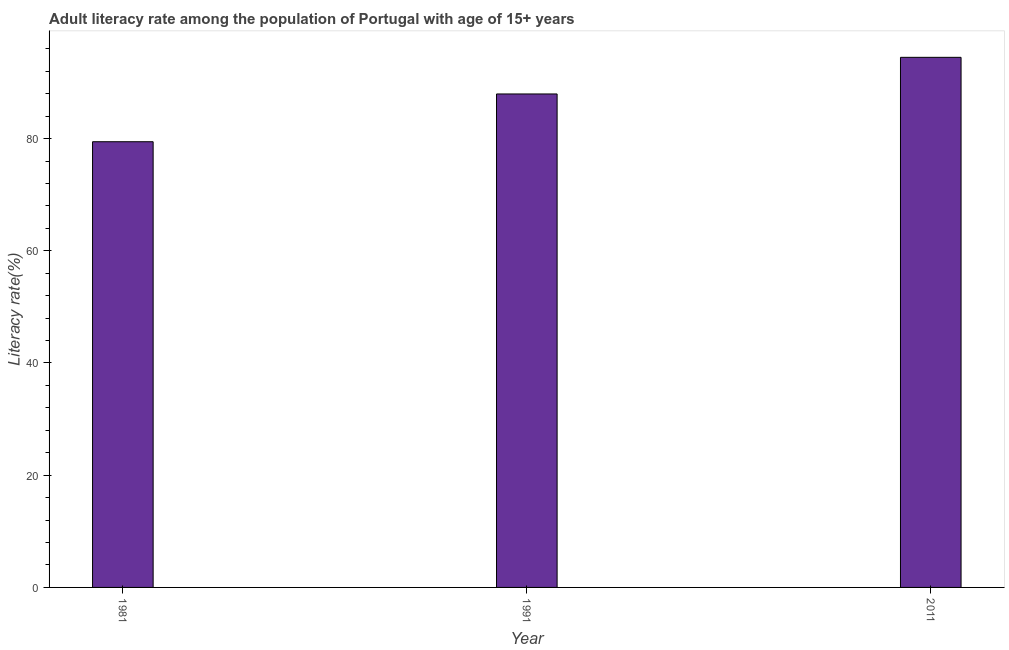Does the graph contain any zero values?
Your response must be concise. No. What is the title of the graph?
Your response must be concise. Adult literacy rate among the population of Portugal with age of 15+ years. What is the label or title of the X-axis?
Your response must be concise. Year. What is the label or title of the Y-axis?
Your response must be concise. Literacy rate(%). What is the adult literacy rate in 2011?
Provide a short and direct response. 94.48. Across all years, what is the maximum adult literacy rate?
Keep it short and to the point. 94.48. Across all years, what is the minimum adult literacy rate?
Give a very brief answer. 79.44. In which year was the adult literacy rate maximum?
Provide a succinct answer. 2011. What is the sum of the adult literacy rate?
Provide a succinct answer. 261.86. What is the difference between the adult literacy rate in 1981 and 1991?
Make the answer very short. -8.51. What is the average adult literacy rate per year?
Make the answer very short. 87.29. What is the median adult literacy rate?
Provide a succinct answer. 87.95. In how many years, is the adult literacy rate greater than 32 %?
Your answer should be very brief. 3. What is the ratio of the adult literacy rate in 1981 to that in 2011?
Your response must be concise. 0.84. What is the difference between the highest and the second highest adult literacy rate?
Keep it short and to the point. 6.53. Is the sum of the adult literacy rate in 1981 and 1991 greater than the maximum adult literacy rate across all years?
Offer a very short reply. Yes. What is the difference between the highest and the lowest adult literacy rate?
Your answer should be very brief. 15.04. In how many years, is the adult literacy rate greater than the average adult literacy rate taken over all years?
Provide a short and direct response. 2. Are all the bars in the graph horizontal?
Your response must be concise. No. What is the Literacy rate(%) in 1981?
Ensure brevity in your answer.  79.44. What is the Literacy rate(%) in 1991?
Keep it short and to the point. 87.95. What is the Literacy rate(%) in 2011?
Give a very brief answer. 94.48. What is the difference between the Literacy rate(%) in 1981 and 1991?
Your answer should be compact. -8.51. What is the difference between the Literacy rate(%) in 1981 and 2011?
Your answer should be compact. -15.04. What is the difference between the Literacy rate(%) in 1991 and 2011?
Keep it short and to the point. -6.53. What is the ratio of the Literacy rate(%) in 1981 to that in 1991?
Ensure brevity in your answer.  0.9. What is the ratio of the Literacy rate(%) in 1981 to that in 2011?
Your response must be concise. 0.84. 